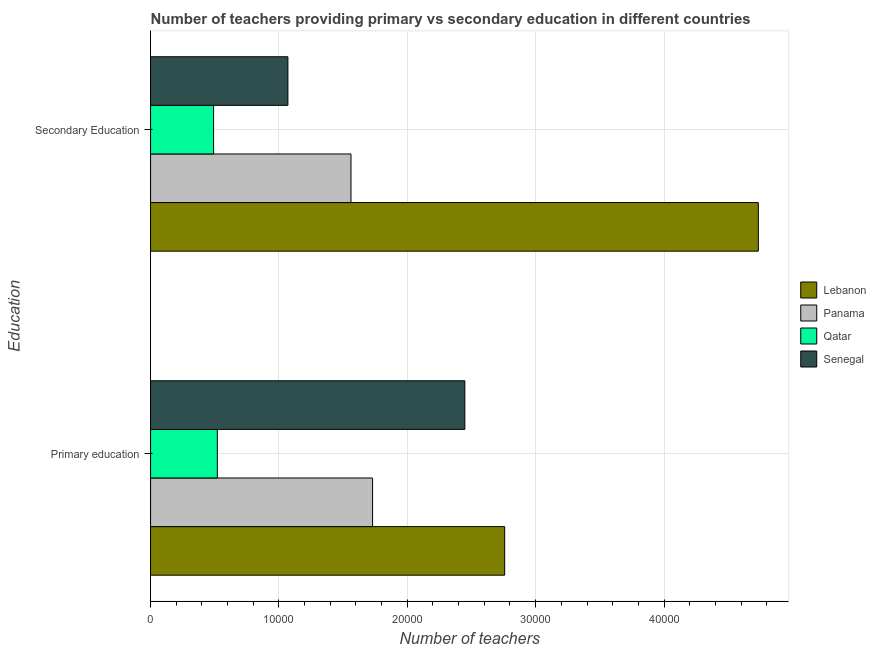How many different coloured bars are there?
Your answer should be compact. 4. How many groups of bars are there?
Ensure brevity in your answer.  2. Are the number of bars per tick equal to the number of legend labels?
Provide a short and direct response. Yes. What is the number of primary teachers in Lebanon?
Give a very brief answer. 2.76e+04. Across all countries, what is the maximum number of secondary teachers?
Give a very brief answer. 4.73e+04. Across all countries, what is the minimum number of primary teachers?
Offer a terse response. 5201. In which country was the number of primary teachers maximum?
Give a very brief answer. Lebanon. In which country was the number of secondary teachers minimum?
Offer a terse response. Qatar. What is the total number of primary teachers in the graph?
Your answer should be very brief. 7.46e+04. What is the difference between the number of primary teachers in Senegal and that in Qatar?
Your answer should be compact. 1.93e+04. What is the difference between the number of secondary teachers in Lebanon and the number of primary teachers in Senegal?
Ensure brevity in your answer.  2.29e+04. What is the average number of secondary teachers per country?
Ensure brevity in your answer.  1.96e+04. What is the difference between the number of secondary teachers and number of primary teachers in Senegal?
Your answer should be compact. -1.38e+04. In how many countries, is the number of secondary teachers greater than 2000 ?
Your response must be concise. 4. What is the ratio of the number of primary teachers in Lebanon to that in Panama?
Your answer should be very brief. 1.59. In how many countries, is the number of secondary teachers greater than the average number of secondary teachers taken over all countries?
Offer a very short reply. 1. What does the 4th bar from the top in Primary education represents?
Your response must be concise. Lebanon. What does the 4th bar from the bottom in Secondary Education represents?
Your answer should be very brief. Senegal. What is the difference between two consecutive major ticks on the X-axis?
Ensure brevity in your answer.  10000. Are the values on the major ticks of X-axis written in scientific E-notation?
Ensure brevity in your answer.  No. Does the graph contain grids?
Your answer should be very brief. Yes. Where does the legend appear in the graph?
Give a very brief answer. Center right. How many legend labels are there?
Offer a very short reply. 4. How are the legend labels stacked?
Keep it short and to the point. Vertical. What is the title of the graph?
Your response must be concise. Number of teachers providing primary vs secondary education in different countries. Does "North America" appear as one of the legend labels in the graph?
Your response must be concise. No. What is the label or title of the X-axis?
Offer a terse response. Number of teachers. What is the label or title of the Y-axis?
Your response must be concise. Education. What is the Number of teachers of Lebanon in Primary education?
Your answer should be very brief. 2.76e+04. What is the Number of teachers in Panama in Primary education?
Give a very brief answer. 1.73e+04. What is the Number of teachers of Qatar in Primary education?
Offer a terse response. 5201. What is the Number of teachers in Senegal in Primary education?
Keep it short and to the point. 2.45e+04. What is the Number of teachers of Lebanon in Secondary Education?
Make the answer very short. 4.73e+04. What is the Number of teachers of Panama in Secondary Education?
Your answer should be compact. 1.56e+04. What is the Number of teachers in Qatar in Secondary Education?
Offer a very short reply. 4909. What is the Number of teachers of Senegal in Secondary Education?
Your response must be concise. 1.07e+04. Across all Education, what is the maximum Number of teachers of Lebanon?
Provide a succinct answer. 4.73e+04. Across all Education, what is the maximum Number of teachers in Panama?
Offer a terse response. 1.73e+04. Across all Education, what is the maximum Number of teachers in Qatar?
Your answer should be very brief. 5201. Across all Education, what is the maximum Number of teachers in Senegal?
Ensure brevity in your answer.  2.45e+04. Across all Education, what is the minimum Number of teachers in Lebanon?
Offer a very short reply. 2.76e+04. Across all Education, what is the minimum Number of teachers in Panama?
Provide a short and direct response. 1.56e+04. Across all Education, what is the minimum Number of teachers in Qatar?
Provide a succinct answer. 4909. Across all Education, what is the minimum Number of teachers of Senegal?
Your response must be concise. 1.07e+04. What is the total Number of teachers of Lebanon in the graph?
Ensure brevity in your answer.  7.49e+04. What is the total Number of teachers in Panama in the graph?
Your answer should be compact. 3.29e+04. What is the total Number of teachers in Qatar in the graph?
Your response must be concise. 1.01e+04. What is the total Number of teachers of Senegal in the graph?
Give a very brief answer. 3.52e+04. What is the difference between the Number of teachers of Lebanon in Primary education and that in Secondary Education?
Give a very brief answer. -1.98e+04. What is the difference between the Number of teachers in Panama in Primary education and that in Secondary Education?
Give a very brief answer. 1683. What is the difference between the Number of teachers of Qatar in Primary education and that in Secondary Education?
Keep it short and to the point. 292. What is the difference between the Number of teachers of Senegal in Primary education and that in Secondary Education?
Provide a short and direct response. 1.38e+04. What is the difference between the Number of teachers in Lebanon in Primary education and the Number of teachers in Panama in Secondary Education?
Provide a short and direct response. 1.20e+04. What is the difference between the Number of teachers in Lebanon in Primary education and the Number of teachers in Qatar in Secondary Education?
Offer a terse response. 2.27e+04. What is the difference between the Number of teachers of Lebanon in Primary education and the Number of teachers of Senegal in Secondary Education?
Ensure brevity in your answer.  1.69e+04. What is the difference between the Number of teachers in Panama in Primary education and the Number of teachers in Qatar in Secondary Education?
Keep it short and to the point. 1.24e+04. What is the difference between the Number of teachers in Panama in Primary education and the Number of teachers in Senegal in Secondary Education?
Your response must be concise. 6597. What is the difference between the Number of teachers of Qatar in Primary education and the Number of teachers of Senegal in Secondary Education?
Provide a succinct answer. -5498. What is the average Number of teachers in Lebanon per Education?
Make the answer very short. 3.75e+04. What is the average Number of teachers in Panama per Education?
Make the answer very short. 1.65e+04. What is the average Number of teachers in Qatar per Education?
Offer a terse response. 5055. What is the average Number of teachers in Senegal per Education?
Your answer should be very brief. 1.76e+04. What is the difference between the Number of teachers in Lebanon and Number of teachers in Panama in Primary education?
Offer a terse response. 1.03e+04. What is the difference between the Number of teachers in Lebanon and Number of teachers in Qatar in Primary education?
Ensure brevity in your answer.  2.24e+04. What is the difference between the Number of teachers of Lebanon and Number of teachers of Senegal in Primary education?
Offer a very short reply. 3102. What is the difference between the Number of teachers in Panama and Number of teachers in Qatar in Primary education?
Provide a succinct answer. 1.21e+04. What is the difference between the Number of teachers in Panama and Number of teachers in Senegal in Primary education?
Keep it short and to the point. -7188. What is the difference between the Number of teachers of Qatar and Number of teachers of Senegal in Primary education?
Your response must be concise. -1.93e+04. What is the difference between the Number of teachers in Lebanon and Number of teachers in Panama in Secondary Education?
Offer a very short reply. 3.17e+04. What is the difference between the Number of teachers of Lebanon and Number of teachers of Qatar in Secondary Education?
Your answer should be compact. 4.24e+04. What is the difference between the Number of teachers in Lebanon and Number of teachers in Senegal in Secondary Education?
Your response must be concise. 3.66e+04. What is the difference between the Number of teachers in Panama and Number of teachers in Qatar in Secondary Education?
Your answer should be very brief. 1.07e+04. What is the difference between the Number of teachers in Panama and Number of teachers in Senegal in Secondary Education?
Your answer should be compact. 4914. What is the difference between the Number of teachers in Qatar and Number of teachers in Senegal in Secondary Education?
Your response must be concise. -5790. What is the ratio of the Number of teachers in Lebanon in Primary education to that in Secondary Education?
Offer a very short reply. 0.58. What is the ratio of the Number of teachers of Panama in Primary education to that in Secondary Education?
Provide a succinct answer. 1.11. What is the ratio of the Number of teachers in Qatar in Primary education to that in Secondary Education?
Provide a short and direct response. 1.06. What is the ratio of the Number of teachers of Senegal in Primary education to that in Secondary Education?
Provide a succinct answer. 2.29. What is the difference between the highest and the second highest Number of teachers of Lebanon?
Keep it short and to the point. 1.98e+04. What is the difference between the highest and the second highest Number of teachers in Panama?
Offer a terse response. 1683. What is the difference between the highest and the second highest Number of teachers of Qatar?
Your answer should be compact. 292. What is the difference between the highest and the second highest Number of teachers of Senegal?
Give a very brief answer. 1.38e+04. What is the difference between the highest and the lowest Number of teachers in Lebanon?
Offer a terse response. 1.98e+04. What is the difference between the highest and the lowest Number of teachers of Panama?
Offer a very short reply. 1683. What is the difference between the highest and the lowest Number of teachers of Qatar?
Your answer should be compact. 292. What is the difference between the highest and the lowest Number of teachers of Senegal?
Keep it short and to the point. 1.38e+04. 